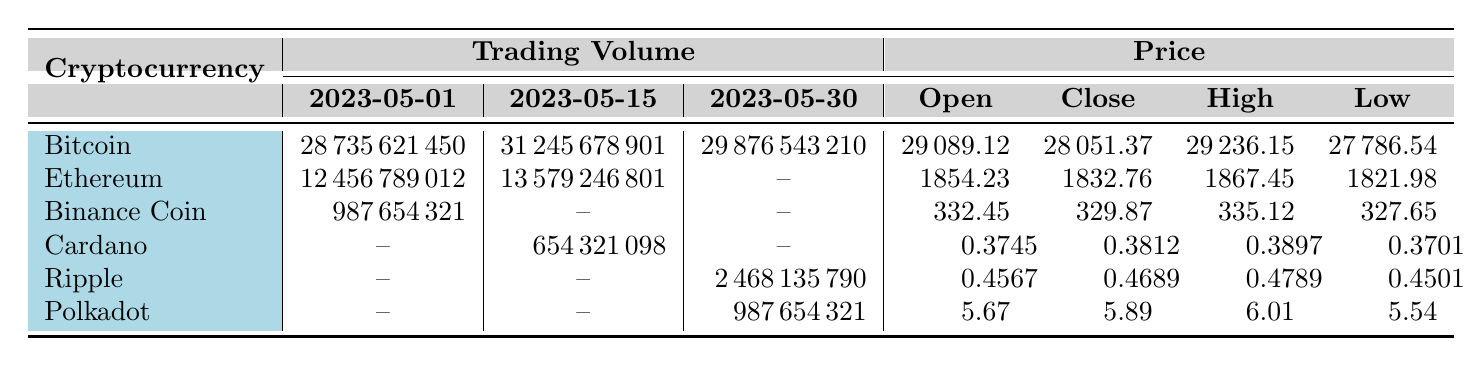What was the trading volume for Bitcoin on May 1, 2023? The table indicates that the trading volume for Bitcoin on May 1, 2023, is listed under the Bitcoin row in the trading volume column for that date. The value is 28735621450.
Answer: 28735621450 What is the highest closing price for Ethereum during the observed dates? To find the highest closing price for Ethereum, we need to check the closing price column for all the available dates. Ethereum's closing prices are 1832.76 (May 1) and 1812.34 (May 15). The highest value is 1832.76.
Answer: 1832.76 Did Binance Coin have any trading volume recorded after May 1, 2023? The table shows that Binance Coin has a trading volume listed only on May 1, 2023, and there is no trading volume recorded for the subsequent dates indicated as "--". Therefore, the answer is no.
Answer: No What was the average trading volume for all cryptocurrencies on May 15, 2023? On May 15, 2023, the trading volumes recorded are 31245678901 (Bitcoin), 13579246801 (Ethereum), and 654321098 (Cardano). To find the average, we sum these values (31245678901 + 13579246801 + 654321098) = 44828056700, then divide by the number of entries (3): 44828056700 / 3 = 14942685566.67.
Answer: 14942685566.67 Which cryptocurrency had the lowest trading volume on May 30, 2023? The table shows trading volumes for May 30, 2023, as follows: 29876543210 (Bitcoin), 2468135790 (Ripple), and 987654321 (Polkadot). Comparing these values, Polkadot has the lowest trading volume at 987654321.
Answer: Polkadot 